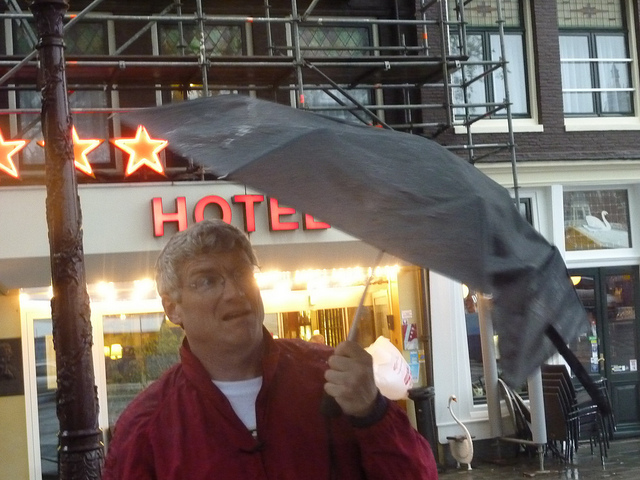What is the weather condition depicted in this image? The weather appears to be quite windy and potentially rainy, as evidenced by the person's inverted umbrella and the wet ground. What does the person's expression tell us about the situation? The person's expression suggests surprise and mild annoyance, likely a reaction to the sudden gust of wind that turned the umbrella inside out. 